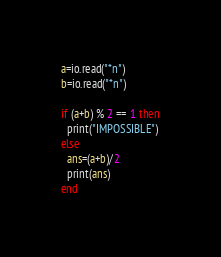Convert code to text. <code><loc_0><loc_0><loc_500><loc_500><_Lua_>a=io.read("*n")
b=io.read("*n")

if (a+b) % 2 == 1 then
  print("IMPOSSIBLE")
else
  ans=(a+b)/2
  print(ans)
end</code> 